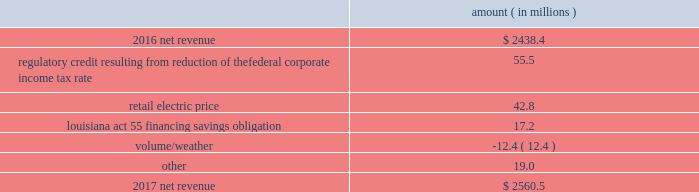Entergy louisiana , llc and subsidiaries management 2019s financial discussion and analysis results of operations net income 2017 compared to 2016 net income decreased $ 305.7 million primarily due to the effect of the enactment of the tax cuts and jobs act , in december 2017 , which resulted in a decrease of $ 182.6 million in net income in 2017 , and the effect of a settlement with the irs related to the 2010-2011 irs audit , which resulted in a $ 136.1 million reduction of income tax expense in 2016 .
Also contributing to the decrease in net income were higher other operation and maintenance expenses .
The decrease was partially offset by higher net revenue and higher other income .
See note 3 to the financial statements for discussion of the effects of the tax cuts and jobs act and the irs audit .
2016 compared to 2015 net income increased $ 175.4 million primarily due to the effect of a settlement with the irs related to the 2010-2011 irs audit , which resulted in a $ 136.1 million reduction of income tax expense in 2016 .
Also contributing to the increase were lower other operation and maintenance expenses , higher net revenue , and higher other income .
The increase was partially offset by higher depreciation and amortization expenses , higher interest expense , and higher nuclear refueling outage expenses .
See note 3 to the financial statements for discussion of the irs audit .
Net revenue 2017 compared to 2016 net revenue consists of operating revenues net of : 1 ) fuel , fuel-related expenses , and gas purchased for resale , 2 ) purchased power expenses , and 3 ) other regulatory charges ( credits ) .
Following is an analysis of the change in net revenue comparing 2017 to 2016 .
Amount ( in millions ) .
The regulatory credit resulting from reduction of the federal corporate income tax rate variance is due to the reduction of the vidalia purchased power agreement regulatory liability by $ 30.5 million and the reduction of the louisiana act 55 financing savings obligation regulatory liabilities by $ 25 million as a result of the enactment of the tax cuts and jobs act , in december 2017 , which lowered the federal corporate income tax rate from 35% ( 35 % ) to 21% ( 21 % ) .
The effects of the tax cuts and jobs act are discussed further in note 3 to the financial statements. .
How much higher was net revenue in 2017 than in 2016 ? ( in millions )? 
Computations: (2560.5 - 2438.4)
Answer: 122.1. 